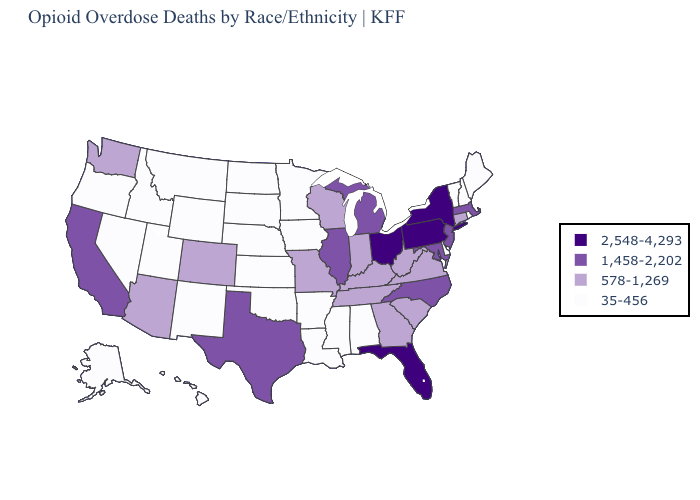What is the value of Indiana?
Concise answer only. 578-1,269. What is the value of Indiana?
Give a very brief answer. 578-1,269. Is the legend a continuous bar?
Write a very short answer. No. Does Washington have the lowest value in the USA?
Keep it brief. No. What is the value of Connecticut?
Keep it brief. 578-1,269. Does Florida have the same value as New York?
Short answer required. Yes. Does the map have missing data?
Write a very short answer. No. Does the map have missing data?
Concise answer only. No. Does Connecticut have a higher value than Georgia?
Concise answer only. No. Name the states that have a value in the range 35-456?
Answer briefly. Alabama, Alaska, Arkansas, Delaware, Hawaii, Idaho, Iowa, Kansas, Louisiana, Maine, Minnesota, Mississippi, Montana, Nebraska, Nevada, New Hampshire, New Mexico, North Dakota, Oklahoma, Oregon, Rhode Island, South Dakota, Utah, Vermont, Wyoming. What is the highest value in the Northeast ?
Write a very short answer. 2,548-4,293. What is the value of Arkansas?
Concise answer only. 35-456. Among the states that border Alabama , which have the highest value?
Give a very brief answer. Florida. Which states hav the highest value in the South?
Quick response, please. Florida. Name the states that have a value in the range 578-1,269?
Answer briefly. Arizona, Colorado, Connecticut, Georgia, Indiana, Kentucky, Missouri, South Carolina, Tennessee, Virginia, Washington, West Virginia, Wisconsin. 